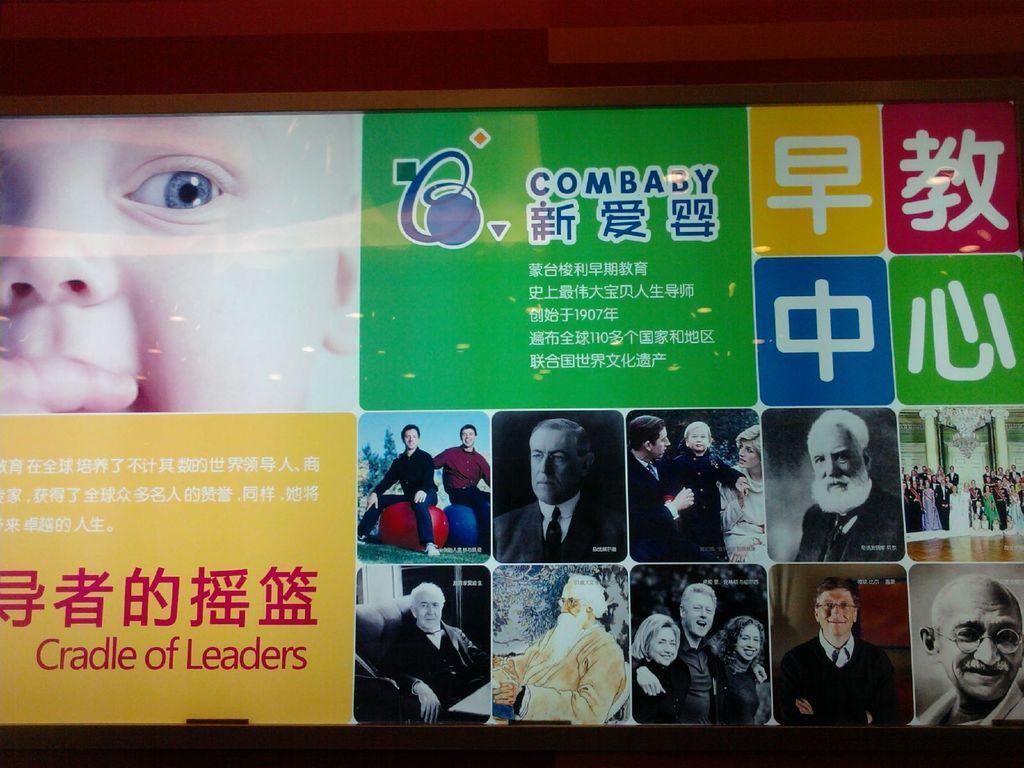Describe this image in one or two sentences. In the picture I can see a board on which we can see many images. Here we can see a baby image on the left side of the image and we can see some text on the yellow and green color background. Here we can see many images of a different person on the right side of the image. 